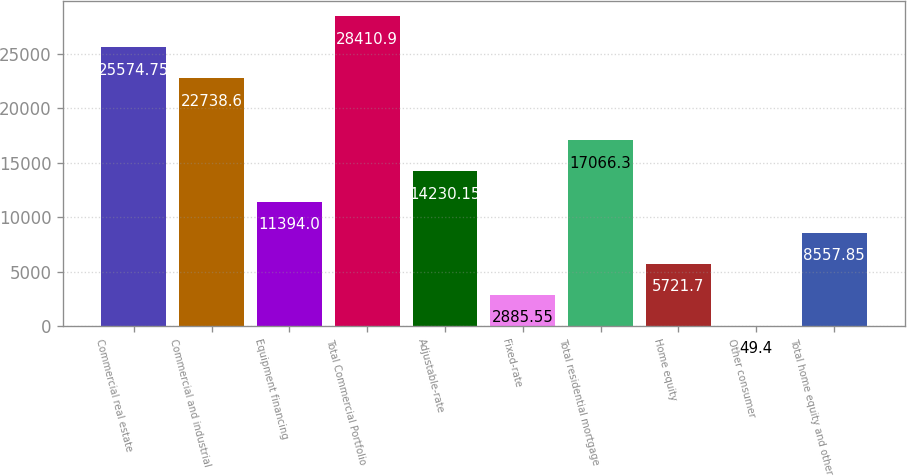Convert chart to OTSL. <chart><loc_0><loc_0><loc_500><loc_500><bar_chart><fcel>Commercial real estate<fcel>Commercial and industrial<fcel>Equipment financing<fcel>Total Commercial Portfolio<fcel>Adjustable-rate<fcel>Fixed-rate<fcel>Total residential mortgage<fcel>Home equity<fcel>Other consumer<fcel>Total home equity and other<nl><fcel>25574.8<fcel>22738.6<fcel>11394<fcel>28410.9<fcel>14230.1<fcel>2885.55<fcel>17066.3<fcel>5721.7<fcel>49.4<fcel>8557.85<nl></chart> 